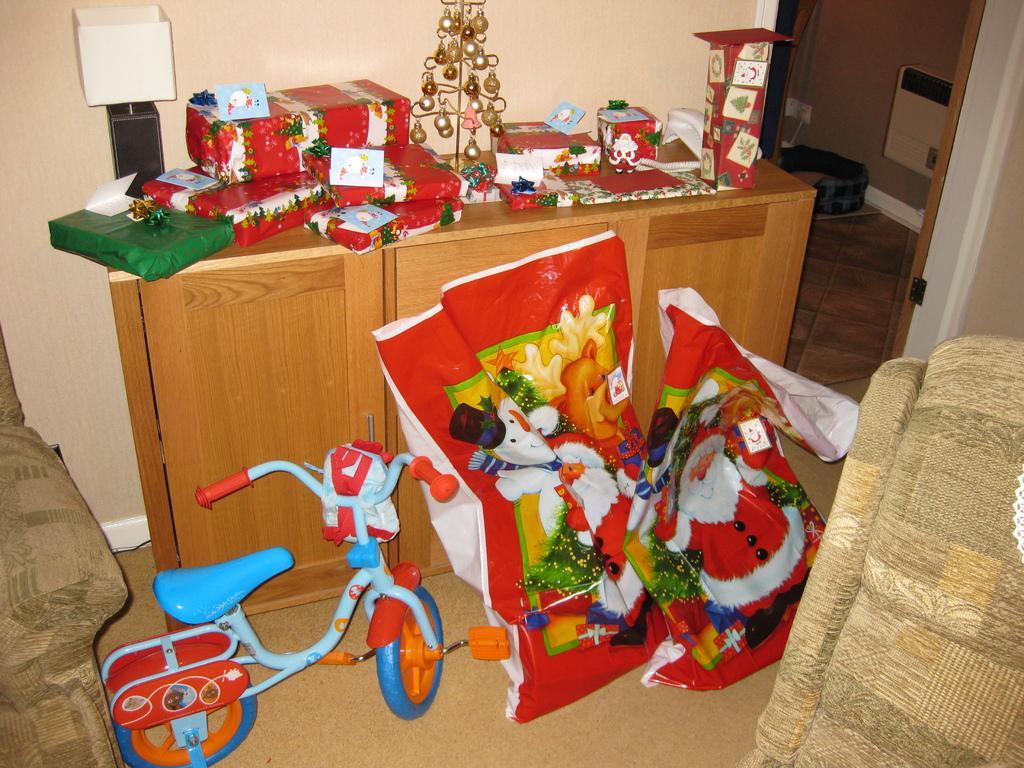How would you summarize this image in a sentence or two? In this image there is an object truncated towards the left of the image, there is an object truncated towards the right of the image, there is a bicycle, there are objects on the ground, there is a wall truncated towards the right of the image, there are objects on the wall, there is a wall truncated towards the top of the image. 